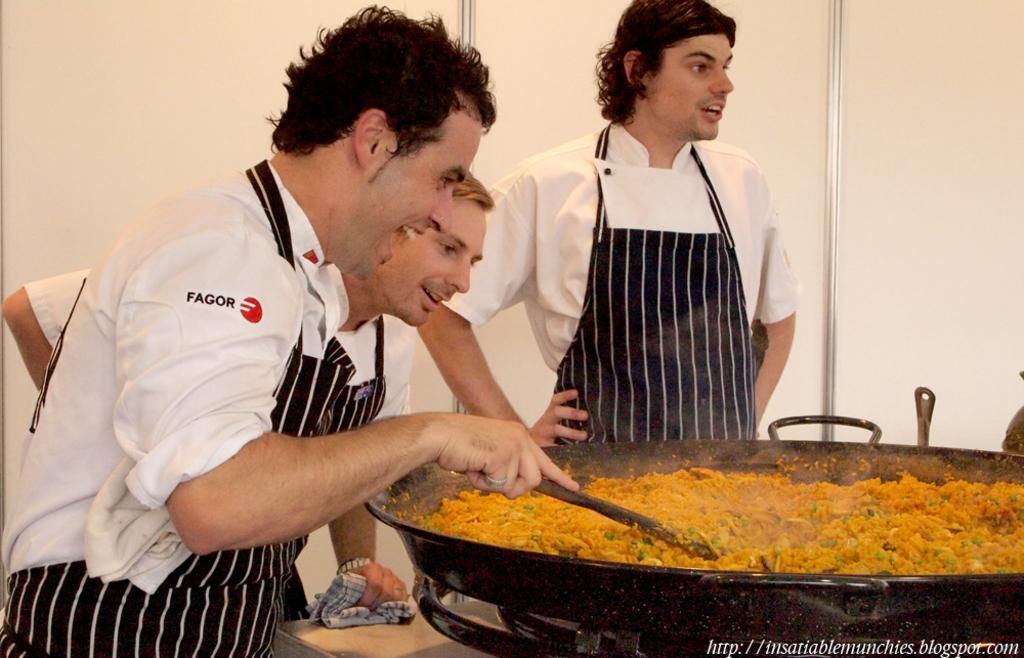In one or two sentences, can you explain what this image depicts? In this image we can see a person cooking food in a pan and holding a stick. And the other person holding a cloth and we can see a person standing near the wall. At the bottom we can see a text written on the poster. 